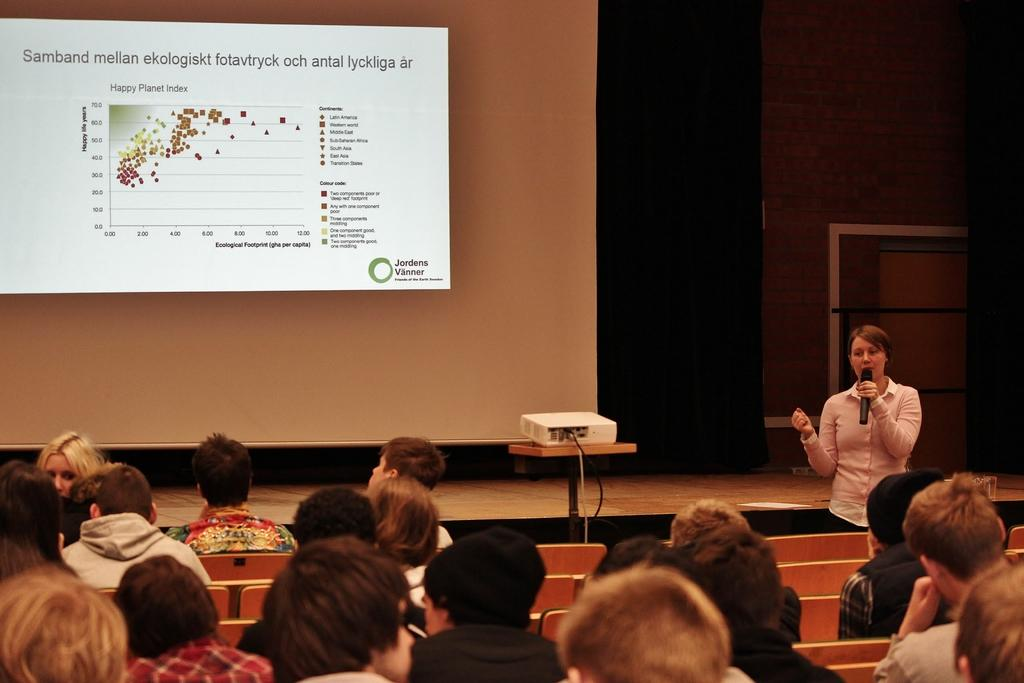What is the main object in the middle of the image? There is a screen in the middle of the image. What can be seen at the bottom of the image? There are chairs at the bottom of the image. How many people are sitting on the chairs? There are multiple persons sitting on the chairs. What is the person on the right side of the image doing? The person on the right side is holding a microphone. What is the income of the person on the left side of the image? There is no information about the income of any person in the image. Is the person on the left side of the image swimming? There is no indication of swimming or any water-related activity in the image. 